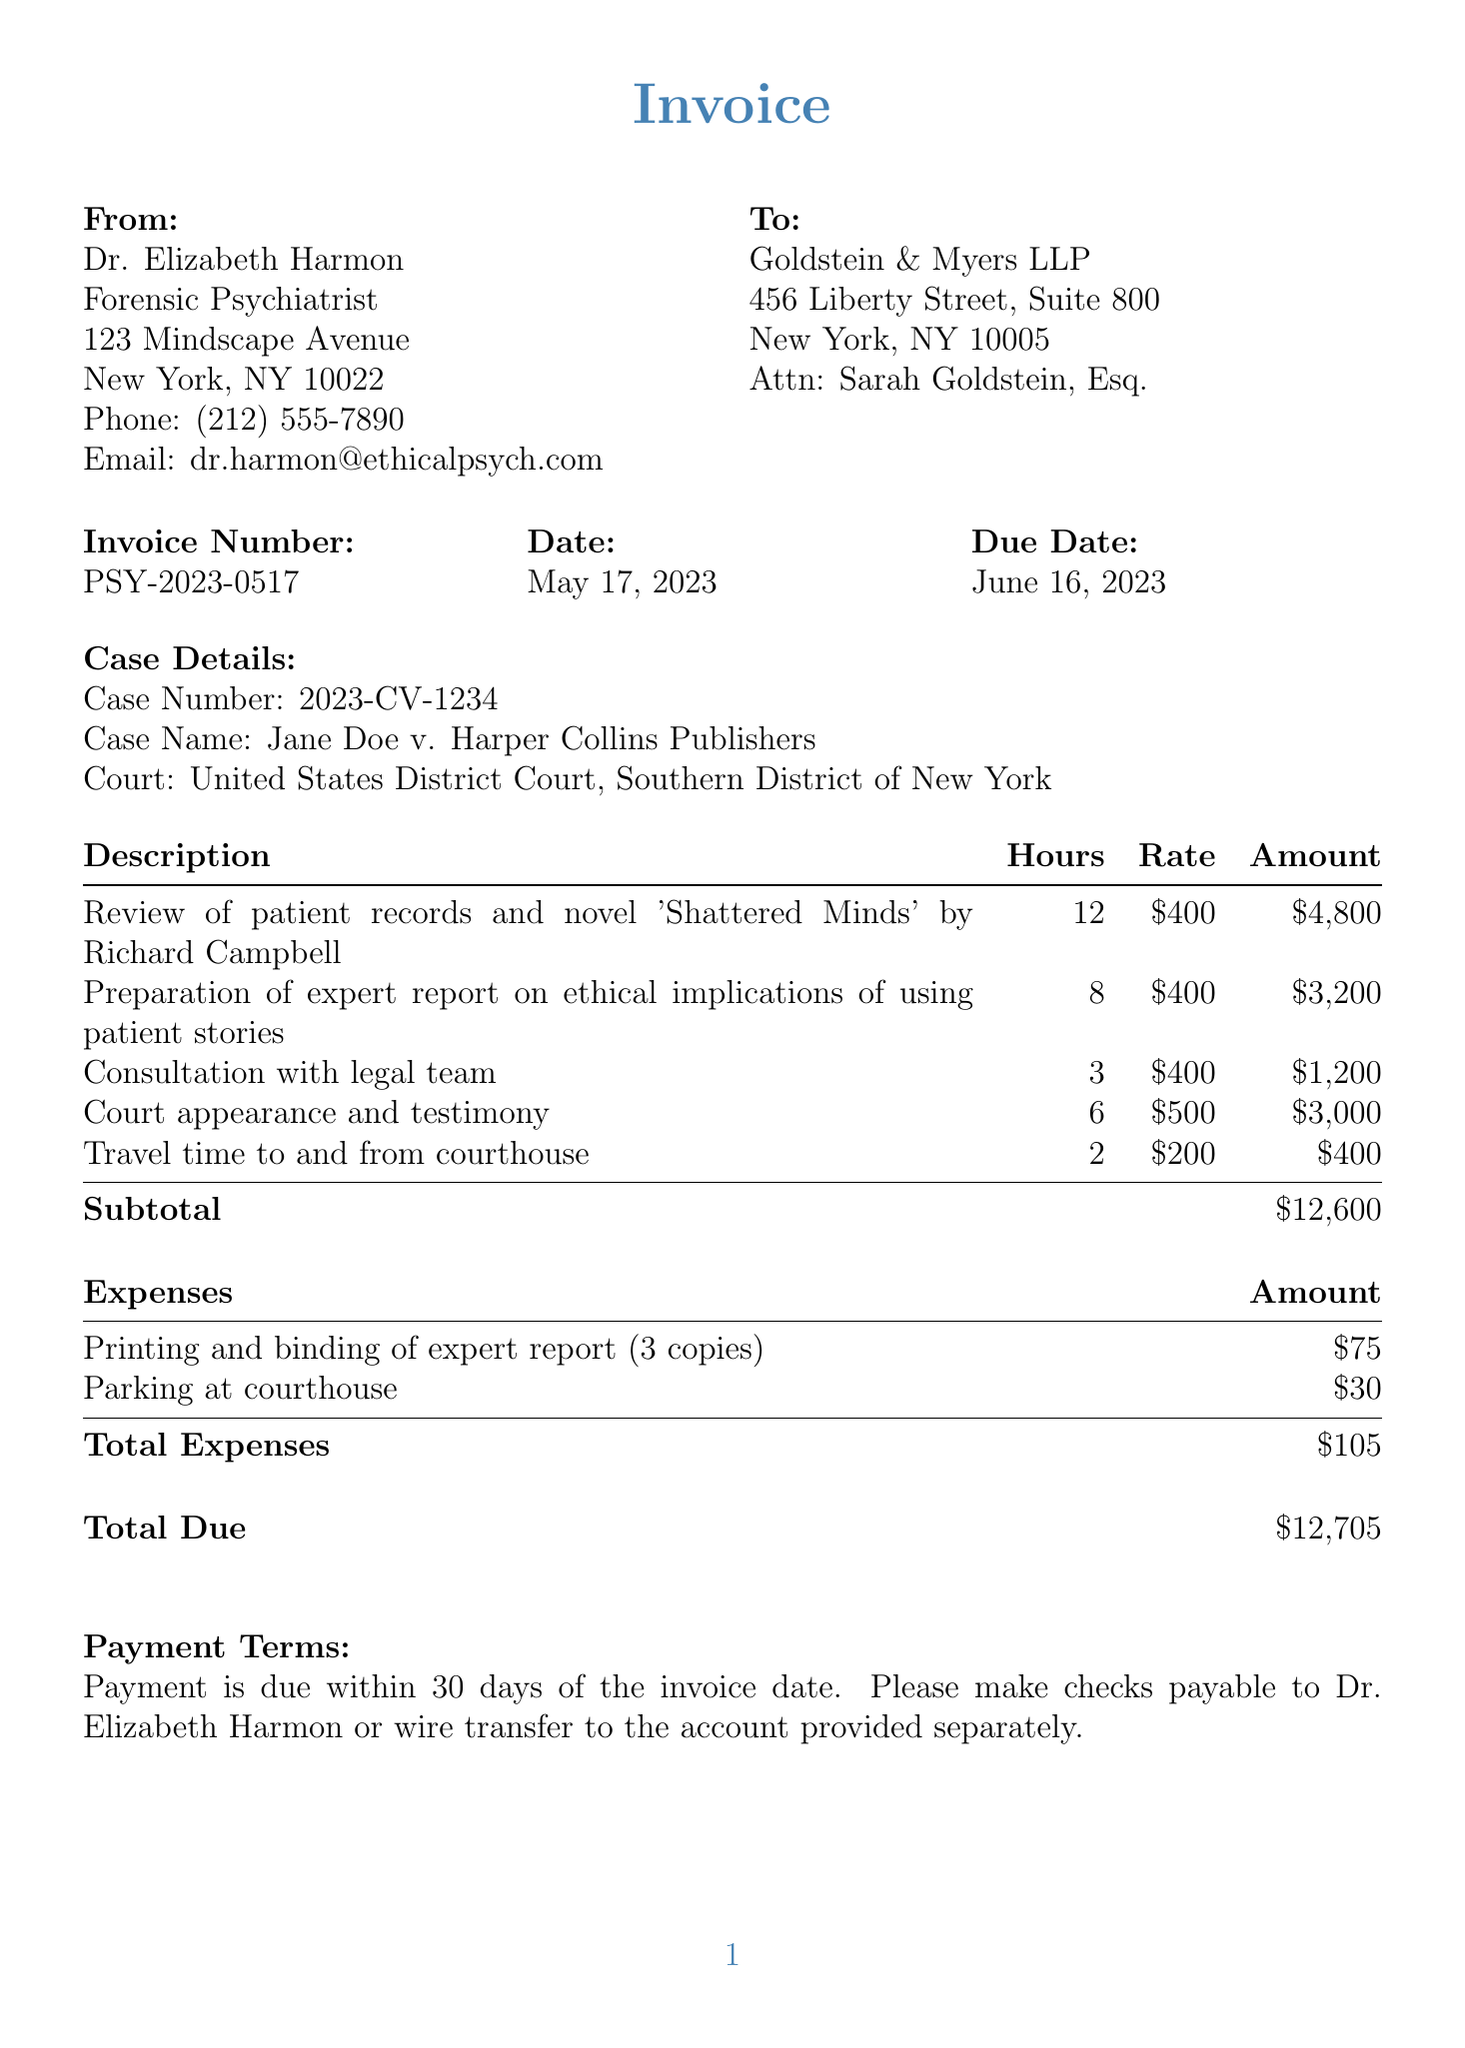What is the invoice number? The invoice number is listed prominently at the top of the document.
Answer: PSY-2023-0517 Who is the expert witness? The expert's name is provided in the expert information section of the document.
Answer: Dr. Elizabeth Harmon What is the total due amount? The total due amount is calculated based on the subtotal and expenses in the invoice.
Answer: $12,705 How many hours were billed for court appearance and testimony? The number of hours for this service is clearly stated in the services section.
Answer: 6 What are the payment terms? The payment terms explain when payment is due and how to make the payment.
Answer: Payment is due within 30 days of the invoice date What is the case name? The case name is stated in the case details section of the document.
Answer: Jane Doe v. Harper Collins Publishers What is the rate per hour for court appearance and testimony? The rate for this particular service is provided in the services section of the invoice.
Answer: $500 What is the amount charged for printing and binding of the expert report? This expense is listed distinctly among the expenses in the document.
Answer: $75 How many copies of the expert report were printed and bound? The document specifies the number of copies included in the expense description.
Answer: 3 